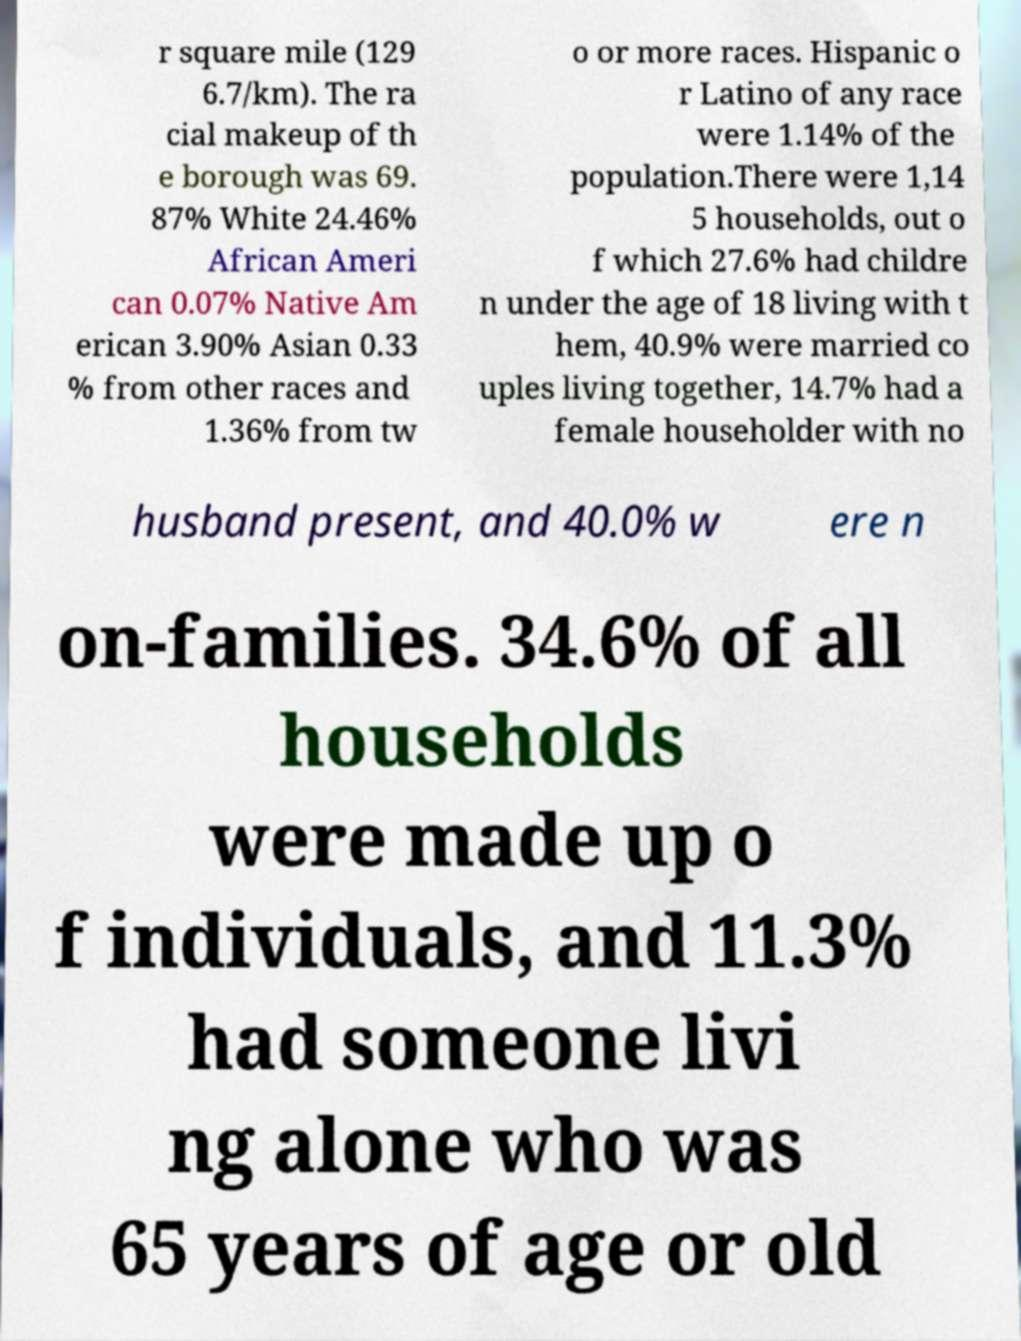There's text embedded in this image that I need extracted. Can you transcribe it verbatim? r square mile (129 6.7/km). The ra cial makeup of th e borough was 69. 87% White 24.46% African Ameri can 0.07% Native Am erican 3.90% Asian 0.33 % from other races and 1.36% from tw o or more races. Hispanic o r Latino of any race were 1.14% of the population.There were 1,14 5 households, out o f which 27.6% had childre n under the age of 18 living with t hem, 40.9% were married co uples living together, 14.7% had a female householder with no husband present, and 40.0% w ere n on-families. 34.6% of all households were made up o f individuals, and 11.3% had someone livi ng alone who was 65 years of age or old 